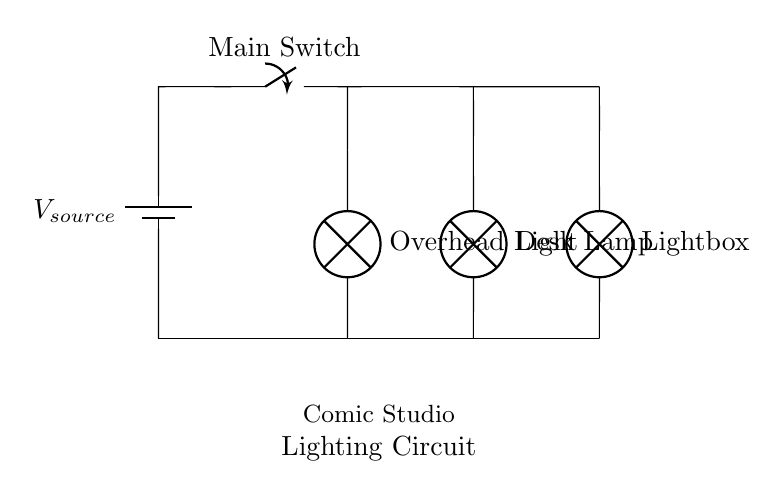What is the main component providing power in this circuit? The main power component is the battery labeled as \(V_{source}\). It serves as the source of electrical energy for the entire circuit.
Answer: Battery What type of circuit is depicted here? The circuit shown is a parallel circuit, as multiple components (lamps) are connected in separate branches with the same voltage across them.
Answer: Parallel Which lighting source is connected to the left branch? The lighting source in the left branch is the Desk Lamp, as indicated by its position connected to the main wire from the switch.
Answer: Desk Lamp How many lighting sources are present in this circuit? There are three lighting sources connected in parallel: the Desk Lamp, Overhead Light, and Lightbox. Each is on its own branch from the main circuit.
Answer: Three If the main switch is closed, what will happen to the lamps? If the main switch is closed, all the lamps will be powered on simultaneously, as they are connected in parallel and each receives full voltage.
Answer: All lamps turn on What might happen if one lamp in this circuit fails? If one lamp fails, the other lamps will continue to function, because the remaining lamps are on separate branches in a parallel configuration.
Answer: Other lamps remain on 